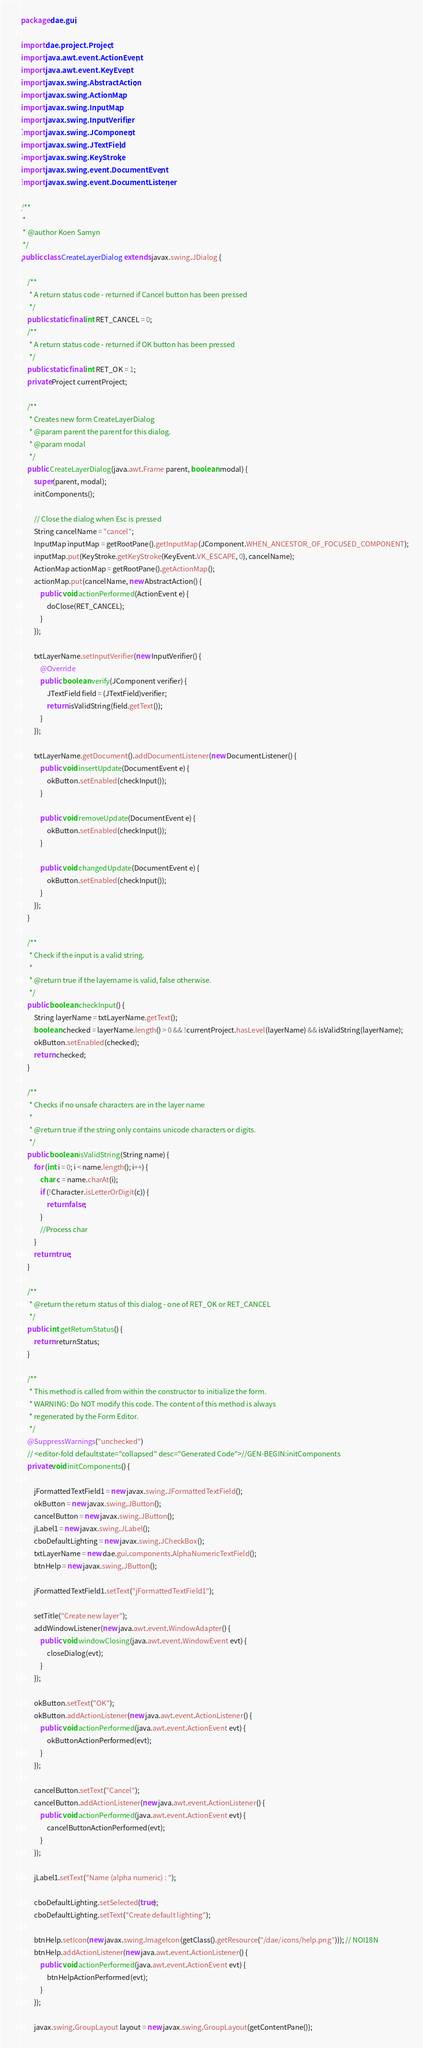Convert code to text. <code><loc_0><loc_0><loc_500><loc_500><_Java_>package dae.gui;

import dae.project.Project;
import java.awt.event.ActionEvent;
import java.awt.event.KeyEvent;
import javax.swing.AbstractAction;
import javax.swing.ActionMap;
import javax.swing.InputMap;
import javax.swing.InputVerifier;
import javax.swing.JComponent;
import javax.swing.JTextField;
import javax.swing.KeyStroke;
import javax.swing.event.DocumentEvent;
import javax.swing.event.DocumentListener;

/**
 *
 * @author Koen Samyn
 */
public class CreateLayerDialog extends javax.swing.JDialog {

    /**
     * A return status code - returned if Cancel button has been pressed
     */
    public static final int RET_CANCEL = 0;
    /**
     * A return status code - returned if OK button has been pressed
     */
    public static final int RET_OK = 1;
    private Project currentProject;

    /**
     * Creates new form CreateLayerDialog
     * @param parent the parent for this dialog.
     * @param modal
     */
    public CreateLayerDialog(java.awt.Frame parent, boolean modal) {
        super(parent, modal);
        initComponents();

        // Close the dialog when Esc is pressed
        String cancelName = "cancel";
        InputMap inputMap = getRootPane().getInputMap(JComponent.WHEN_ANCESTOR_OF_FOCUSED_COMPONENT);
        inputMap.put(KeyStroke.getKeyStroke(KeyEvent.VK_ESCAPE, 0), cancelName);
        ActionMap actionMap = getRootPane().getActionMap();
        actionMap.put(cancelName, new AbstractAction() {
            public void actionPerformed(ActionEvent e) {
                doClose(RET_CANCEL);
            }
        });

        txtLayerName.setInputVerifier(new InputVerifier() {
            @Override
            public boolean verify(JComponent verifier) {
                JTextField field = (JTextField)verifier;
                return isValidString(field.getText());
            }
        });

        txtLayerName.getDocument().addDocumentListener(new DocumentListener() {
            public void insertUpdate(DocumentEvent e) {
                okButton.setEnabled(checkInput());
            }

            public void removeUpdate(DocumentEvent e) {
                okButton.setEnabled(checkInput());
            }

            public void changedUpdate(DocumentEvent e) {
                okButton.setEnabled(checkInput());
            }
        });
    }

    /**
     * Check if the input is a valid string.
     *
     * @return true if the layername is valid, false otherwise.
     */
    public boolean checkInput() {
        String layerName = txtLayerName.getText();
        boolean checked = layerName.length() > 0 && !currentProject.hasLevel(layerName) && isValidString(layerName);
        okButton.setEnabled(checked);
        return checked;
    }

    /**
     * Checks if no unsafe characters are in the layer name
     *
     * @return true if the string only contains unicode characters or digits.
     */
    public boolean isValidString(String name) {
        for (int i = 0; i < name.length(); i++) {
            char c = name.charAt(i);
            if (!Character.isLetterOrDigit(c)) {
                return false;
            }
            //Process char
        }
        return true;
    }

    /**
     * @return the return status of this dialog - one of RET_OK or RET_CANCEL
     */
    public int getReturnStatus() {
        return returnStatus;
    }

    /**
     * This method is called from within the constructor to initialize the form.
     * WARNING: Do NOT modify this code. The content of this method is always
     * regenerated by the Form Editor.
     */
    @SuppressWarnings("unchecked")
    // <editor-fold defaultstate="collapsed" desc="Generated Code">//GEN-BEGIN:initComponents
    private void initComponents() {

        jFormattedTextField1 = new javax.swing.JFormattedTextField();
        okButton = new javax.swing.JButton();
        cancelButton = new javax.swing.JButton();
        jLabel1 = new javax.swing.JLabel();
        cboDefaultLighting = new javax.swing.JCheckBox();
        txtLayerName = new dae.gui.components.AlphaNumericTextField();
        btnHelp = new javax.swing.JButton();

        jFormattedTextField1.setText("jFormattedTextField1");

        setTitle("Create new layer");
        addWindowListener(new java.awt.event.WindowAdapter() {
            public void windowClosing(java.awt.event.WindowEvent evt) {
                closeDialog(evt);
            }
        });

        okButton.setText("OK");
        okButton.addActionListener(new java.awt.event.ActionListener() {
            public void actionPerformed(java.awt.event.ActionEvent evt) {
                okButtonActionPerformed(evt);
            }
        });

        cancelButton.setText("Cancel");
        cancelButton.addActionListener(new java.awt.event.ActionListener() {
            public void actionPerformed(java.awt.event.ActionEvent evt) {
                cancelButtonActionPerformed(evt);
            }
        });

        jLabel1.setText("Name (alpha numeric) : ");

        cboDefaultLighting.setSelected(true);
        cboDefaultLighting.setText("Create default lighting");

        btnHelp.setIcon(new javax.swing.ImageIcon(getClass().getResource("/dae/icons/help.png"))); // NOI18N
        btnHelp.addActionListener(new java.awt.event.ActionListener() {
            public void actionPerformed(java.awt.event.ActionEvent evt) {
                btnHelpActionPerformed(evt);
            }
        });

        javax.swing.GroupLayout layout = new javax.swing.GroupLayout(getContentPane());</code> 